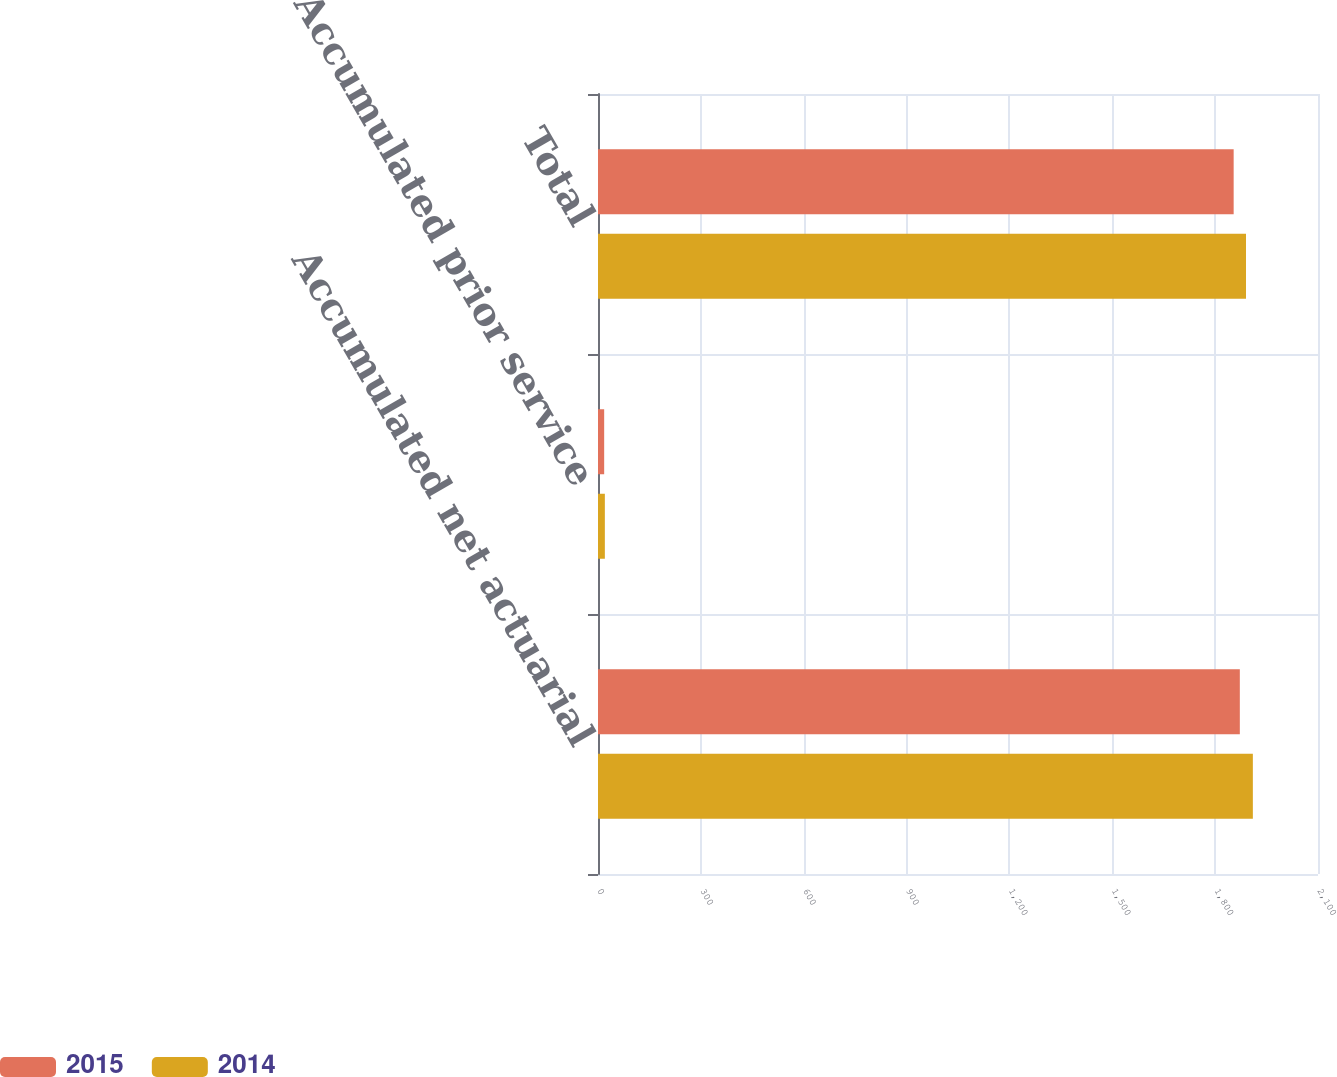Convert chart to OTSL. <chart><loc_0><loc_0><loc_500><loc_500><stacked_bar_chart><ecel><fcel>Accumulated net actuarial<fcel>Accumulated prior service<fcel>Total<nl><fcel>2015<fcel>1872<fcel>18<fcel>1854<nl><fcel>2014<fcel>1910<fcel>20<fcel>1890<nl></chart> 